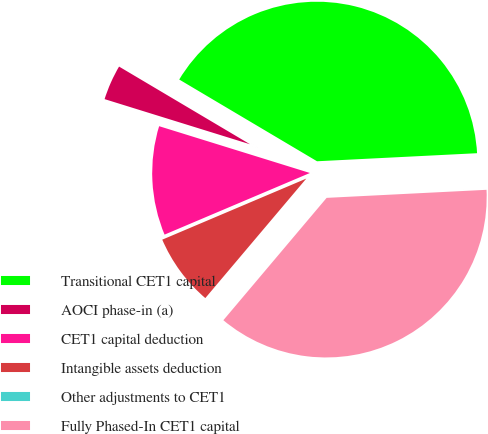Convert chart to OTSL. <chart><loc_0><loc_0><loc_500><loc_500><pie_chart><fcel>Transitional CET1 capital<fcel>AOCI phase-in (a)<fcel>CET1 capital deduction<fcel>Intangible assets deduction<fcel>Other adjustments to CET1<fcel>Fully Phased-In CET1 capital<nl><fcel>40.67%<fcel>3.73%<fcel>11.17%<fcel>7.45%<fcel>0.01%<fcel>36.95%<nl></chart> 